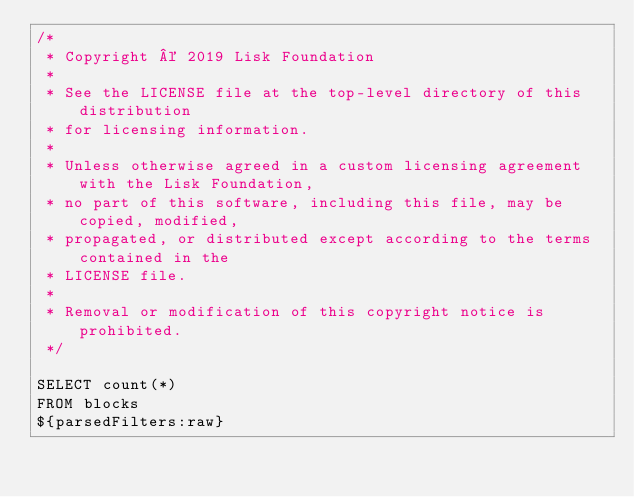<code> <loc_0><loc_0><loc_500><loc_500><_SQL_>/*
 * Copyright © 2019 Lisk Foundation
 *
 * See the LICENSE file at the top-level directory of this distribution
 * for licensing information.
 *
 * Unless otherwise agreed in a custom licensing agreement with the Lisk Foundation,
 * no part of this software, including this file, may be copied, modified,
 * propagated, or distributed except according to the terms contained in the
 * LICENSE file.
 *
 * Removal or modification of this copyright notice is prohibited.
 */

SELECT count(*)
FROM blocks
${parsedFilters:raw}
</code> 